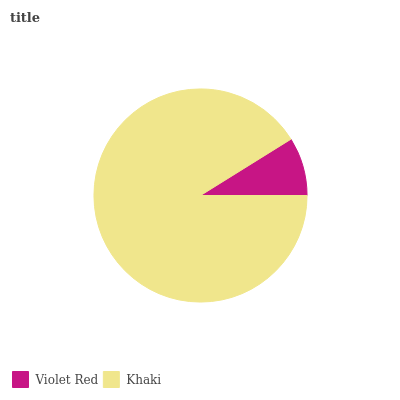Is Violet Red the minimum?
Answer yes or no. Yes. Is Khaki the maximum?
Answer yes or no. Yes. Is Khaki the minimum?
Answer yes or no. No. Is Khaki greater than Violet Red?
Answer yes or no. Yes. Is Violet Red less than Khaki?
Answer yes or no. Yes. Is Violet Red greater than Khaki?
Answer yes or no. No. Is Khaki less than Violet Red?
Answer yes or no. No. Is Khaki the high median?
Answer yes or no. Yes. Is Violet Red the low median?
Answer yes or no. Yes. Is Violet Red the high median?
Answer yes or no. No. Is Khaki the low median?
Answer yes or no. No. 